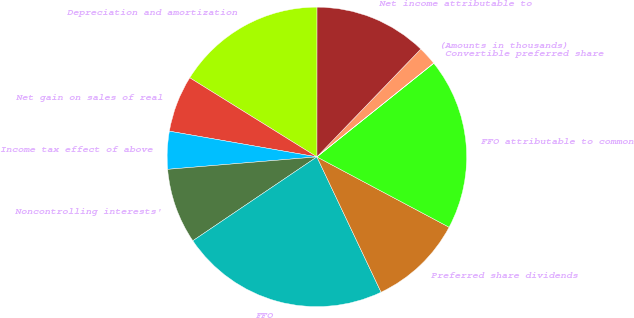Convert chart. <chart><loc_0><loc_0><loc_500><loc_500><pie_chart><fcel>(Amounts in thousands)<fcel>Net income attributable to<fcel>Depreciation and amortization<fcel>Net gain on sales of real<fcel>Income tax effect of above<fcel>Noncontrolling interests'<fcel>FFO<fcel>Preferred share dividends<fcel>FFO attributable to common<fcel>Convertible preferred share<nl><fcel>2.04%<fcel>12.2%<fcel>16.15%<fcel>6.11%<fcel>4.07%<fcel>8.14%<fcel>22.59%<fcel>10.17%<fcel>18.53%<fcel>0.01%<nl></chart> 